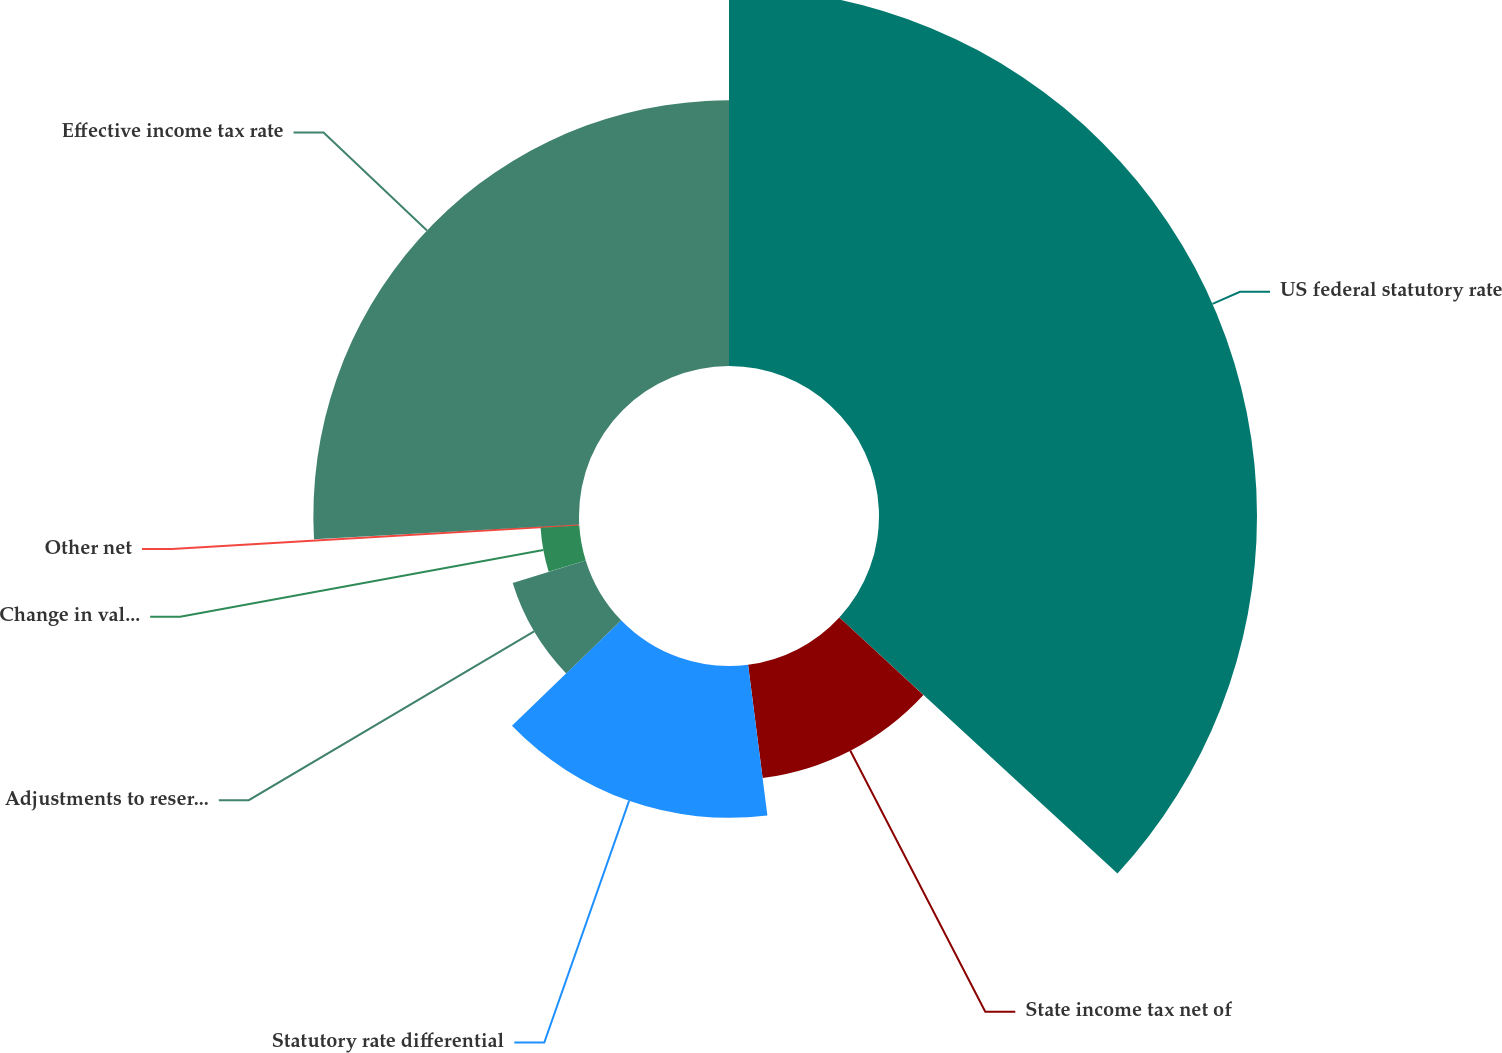<chart> <loc_0><loc_0><loc_500><loc_500><pie_chart><fcel>US federal statutory rate<fcel>State income tax net of<fcel>Statutory rate differential<fcel>Adjustments to reserves and<fcel>Change in valuation allowances<fcel>Other net<fcel>Effective income tax rate<nl><fcel>36.84%<fcel>11.13%<fcel>14.8%<fcel>7.45%<fcel>3.78%<fcel>0.11%<fcel>25.89%<nl></chart> 